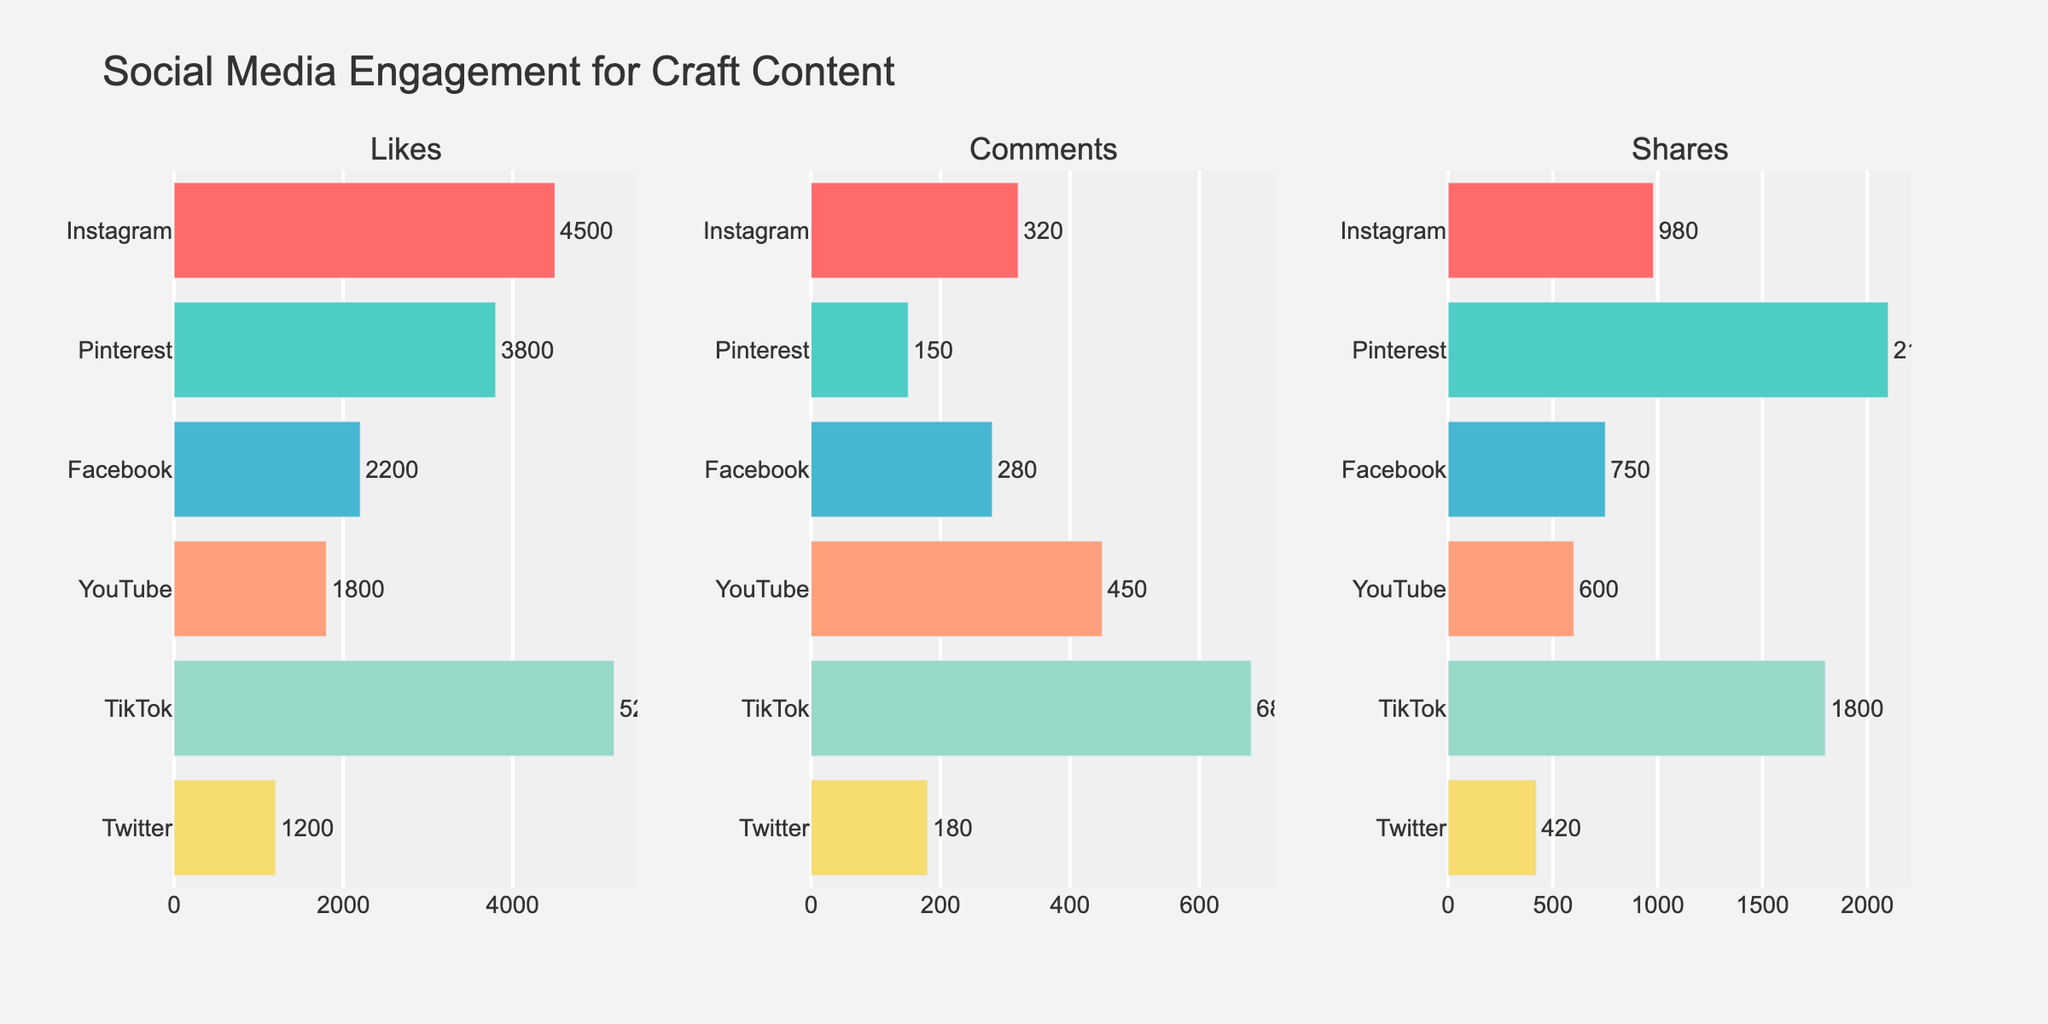What is the title of the figure? The title is usually displayed prominently at the top of the figure. We can read the title directly to find the answer.
Answer: Social Media Engagement for Craft Content Which platform has the highest number of likes? To find which platform has the highest number of likes, look at the first subplot and identify the longest bar in the 'Likes' category.
Answer: TikTok How many comments does YouTube have? Look at the 'Comments' subplot (middle subplot) and find the bar corresponding to YouTube. The number above or next to the bar indicates the number of comments.
Answer: 450 How does the number of shares on Pinterest compare to that on Facebook? Check the 'Shares' subplot (rightmost subplot) and compare the lengths of the bars for Pinterest and Facebook. The text next to the bars will help in precise comparison.
Answer: Pinterest has 1350 shares more than Facebook Which platform has the lowest engagement in terms of comments? Look at the 'Comments' subplot and identify the shortest bar. Read the label next to the bar to find the platform.
Answer: Pinterest What is the total number of likes across all platforms? Sum the number of likes for each platform by looking at the 'Likes' plot: 4500 (Instagram) + 3800 (Pinterest) + 2200 (Facebook) + 1800 (YouTube) + 5200 (TikTok) + 1200 (Twitter).
Answer: 18700 Which platform has more likes: Instagram or Facebook? Look at the 'Likes' subplot and compare the lengths of the bars for Instagram and Facebook. The text next to the bars gives the exact numbers.
Answer: Instagram What is the average number of shares across all platforms? Sum the shares: 980 (Instagram) + 2100 (Pinterest) + 750 (Facebook) + 600 (YouTube) + 1800 (TikTok) + 420 (Twitter). There are 6 platforms, so divide the sum by 6. Sum = 6650, Average = 6650 / 6.
Answer: 1108.33 How many more likes does TikTok have compared to YouTube? Find the likes for TikTok and YouTube from the 'Likes' subplot and subtract the smaller number from the larger one. TikTok has 5200 likes and YouTube has 1800 likes. 5200 - 1800 = 3400.
Answer: 3400 Rank the platforms in descending order based on the number of shares. Look at the 'Shares' subplot and list the platforms from the longest bar to the shortest: Pinterest (2100), TikTok (1800), Instagram (980), Facebook (750), YouTube (600), Twitter (420).
Answer: Pinterest, TikTok, Instagram, Facebook, YouTube, Twitter Across which platform does craft content receive the most engagement in terms of comments? Check the 'Comments' subplot and identify the platform with the longest bar.
Answer: TikTok 